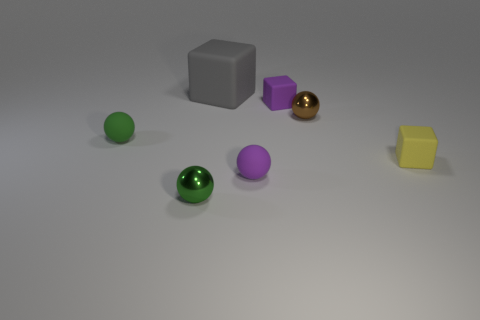Subtract all green metal spheres. How many spheres are left? 3 Subtract all blue cubes. How many green balls are left? 2 Subtract all purple cubes. How many cubes are left? 2 Add 1 tiny matte blocks. How many objects exist? 8 Subtract 1 blocks. How many blocks are left? 2 Subtract all cubes. How many objects are left? 4 Add 6 tiny rubber things. How many tiny rubber things are left? 10 Add 2 tiny brown spheres. How many tiny brown spheres exist? 3 Subtract 0 green blocks. How many objects are left? 7 Subtract all red spheres. Subtract all gray blocks. How many spheres are left? 4 